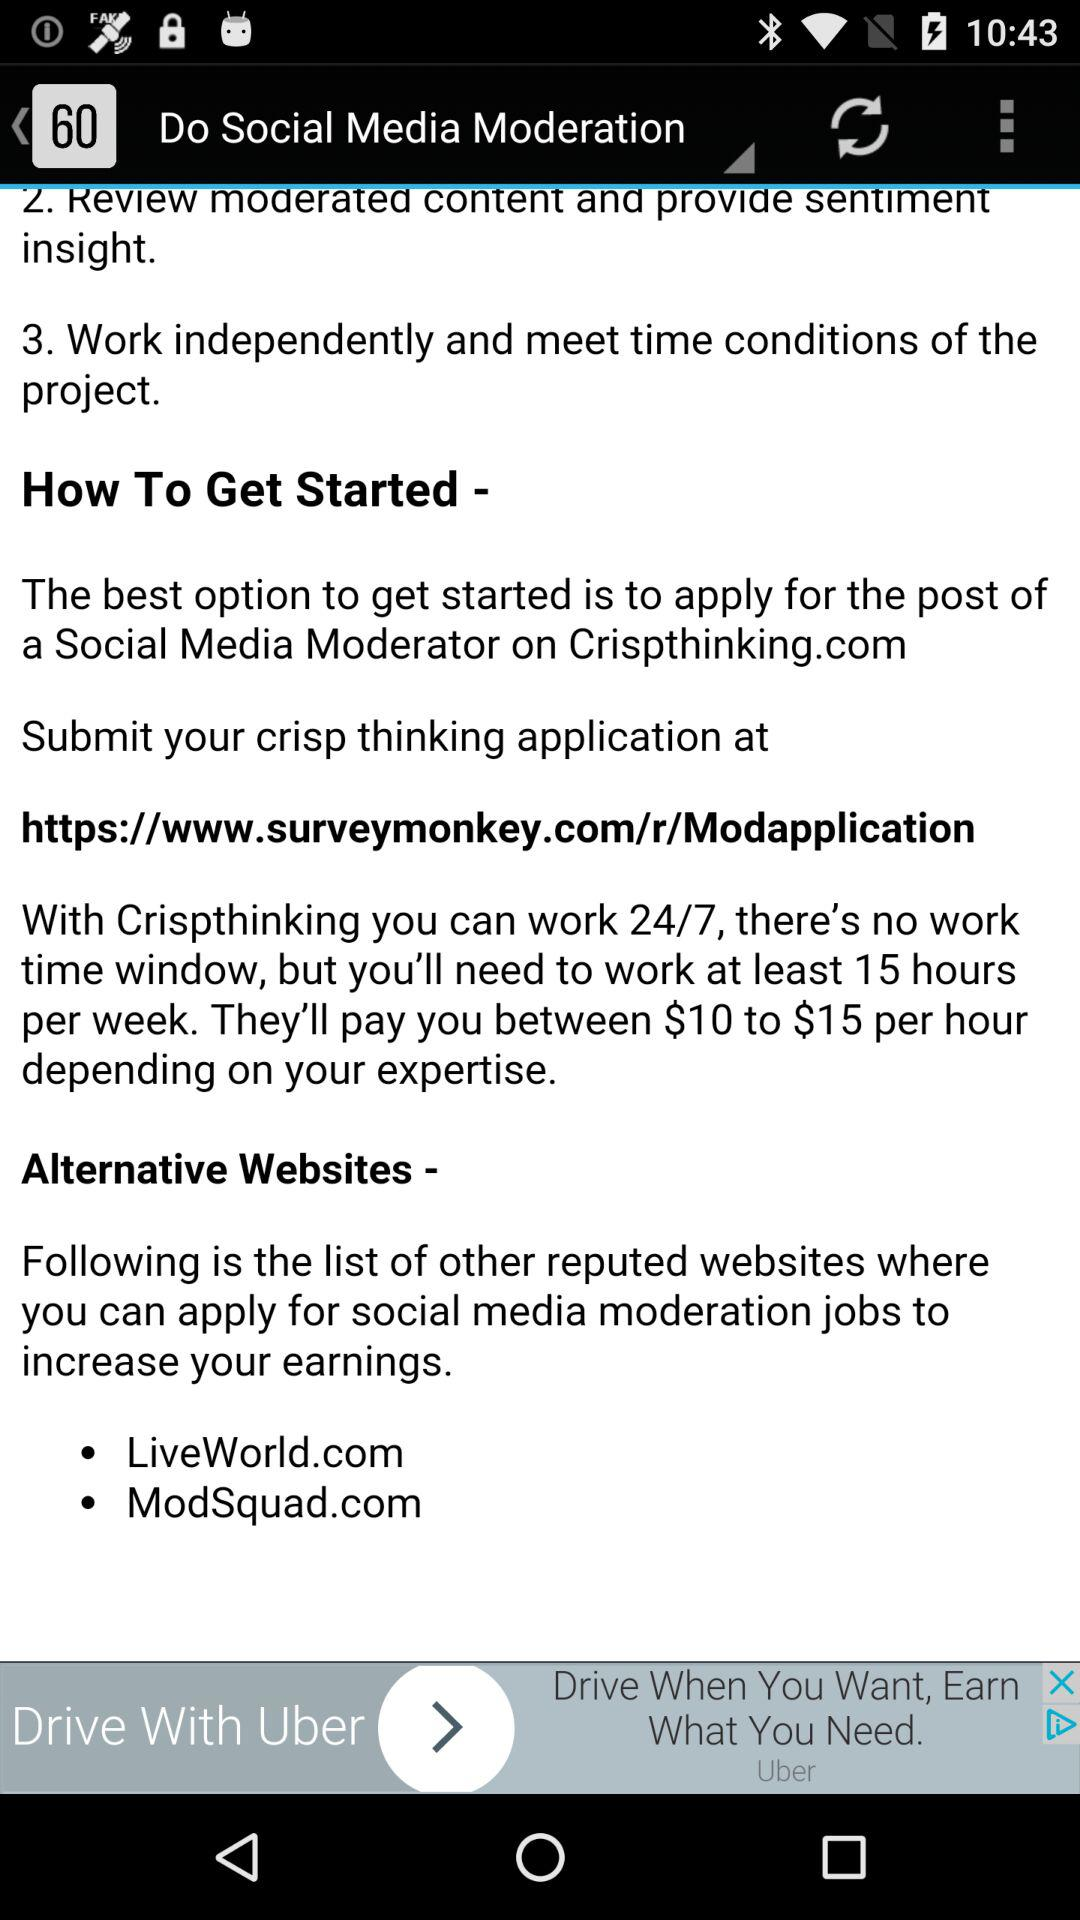What are the alternative websites? The alternative websites are "LiveWorld.com" and "ModSquad.com". 